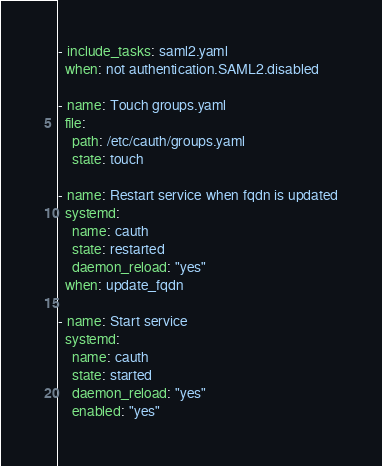<code> <loc_0><loc_0><loc_500><loc_500><_YAML_>
- include_tasks: saml2.yaml
  when: not authentication.SAML2.disabled

- name: Touch groups.yaml
  file:
    path: /etc/cauth/groups.yaml
    state: touch

- name: Restart service when fqdn is updated
  systemd:
    name: cauth
    state: restarted
    daemon_reload: "yes"
  when: update_fqdn

- name: Start service
  systemd:
    name: cauth
    state: started
    daemon_reload: "yes"
    enabled: "yes"
</code> 